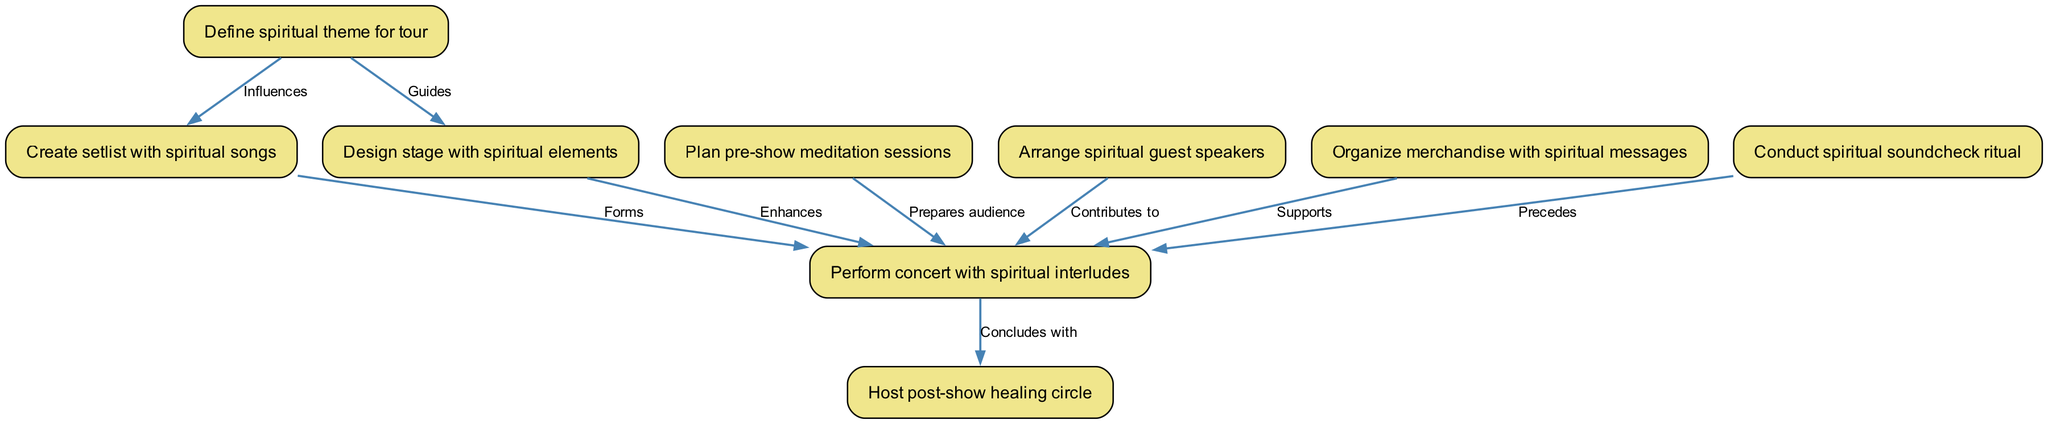What is the first step in the concert planning process? The diagram indicates that the first step is to "Define spiritual theme for tour," which is the top node in the flowchart.
Answer: Define spiritual theme for tour How many nodes are present in the diagram? By counting the nodes listed in the data, we find that there are nine different steps or activities involved in the concert tour planning process.
Answer: 9 What does "Design stage with spiritual elements" influence? This node influences "Perform concert with spiritual interludes," indicating that the stage design impacts the performance's content.
Answer: Perform concert with spiritual interludes What precedes the concert performance? The node "Conduct spiritual soundcheck ritual" is connected to the concert performance node, indicating that it comes just before the performance, ensuring the right spiritual atmosphere.
Answer: Conduct spiritual soundcheck ritual What is the concluded activity after the concert? The diagram shows that the concert performance concludes with a "Host post-show healing circle," signifying the closing activity of the tour.
Answer: Host post-show healing circle Which two nodes contribute to the main concert performance? The nodes "Arrange spiritual guest speakers" and "Organize merchandise with spiritual messages" both contribute to enhancing the overall concert experience, as shown through their connections to the performance node.
Answer: Arrange spiritual guest speakers, Organize merchandise with spiritual messages 